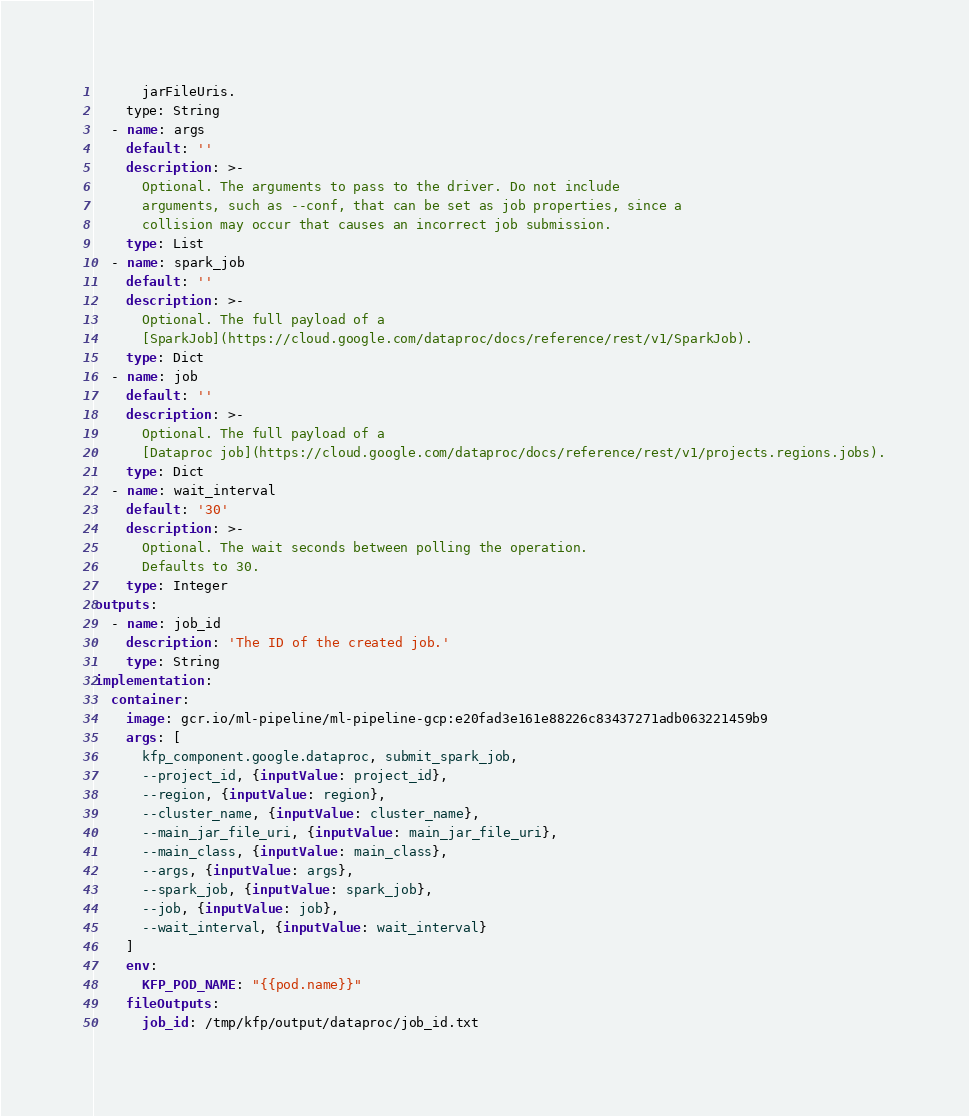<code> <loc_0><loc_0><loc_500><loc_500><_YAML_>      jarFileUris.
    type: String
  - name: args
    default: ''
    description: >-
      Optional. The arguments to pass to the driver. Do not include 
      arguments, such as --conf, that can be set as job properties, since a 
      collision may occur that causes an incorrect job submission.
    type: List
  - name: spark_job
    default: ''
    description: >-
      Optional. The full payload of a
      [SparkJob](https://cloud.google.com/dataproc/docs/reference/rest/v1/SparkJob).
    type: Dict
  - name: job
    default: ''
    description: >-
      Optional. The full payload of a
      [Dataproc job](https://cloud.google.com/dataproc/docs/reference/rest/v1/projects.regions.jobs).
    type: Dict
  - name: wait_interval
    default: '30'
    description: >-
      Optional. The wait seconds between polling the operation.
      Defaults to 30.
    type: Integer
outputs:
  - name: job_id
    description: 'The ID of the created job.'
    type: String
implementation:
  container:
    image: gcr.io/ml-pipeline/ml-pipeline-gcp:e20fad3e161e88226c83437271adb063221459b9
    args: [
      kfp_component.google.dataproc, submit_spark_job,
      --project_id, {inputValue: project_id},
      --region, {inputValue: region},
      --cluster_name, {inputValue: cluster_name},
      --main_jar_file_uri, {inputValue: main_jar_file_uri},
      --main_class, {inputValue: main_class},
      --args, {inputValue: args},
      --spark_job, {inputValue: spark_job},
      --job, {inputValue: job},
      --wait_interval, {inputValue: wait_interval}
    ]
    env:
      KFP_POD_NAME: "{{pod.name}}"
    fileOutputs:
      job_id: /tmp/kfp/output/dataproc/job_id.txt</code> 